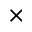Convert formula to latex. <formula><loc_0><loc_0><loc_500><loc_500>\times</formula> 